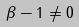Convert formula to latex. <formula><loc_0><loc_0><loc_500><loc_500>\beta - 1 \ne 0</formula> 